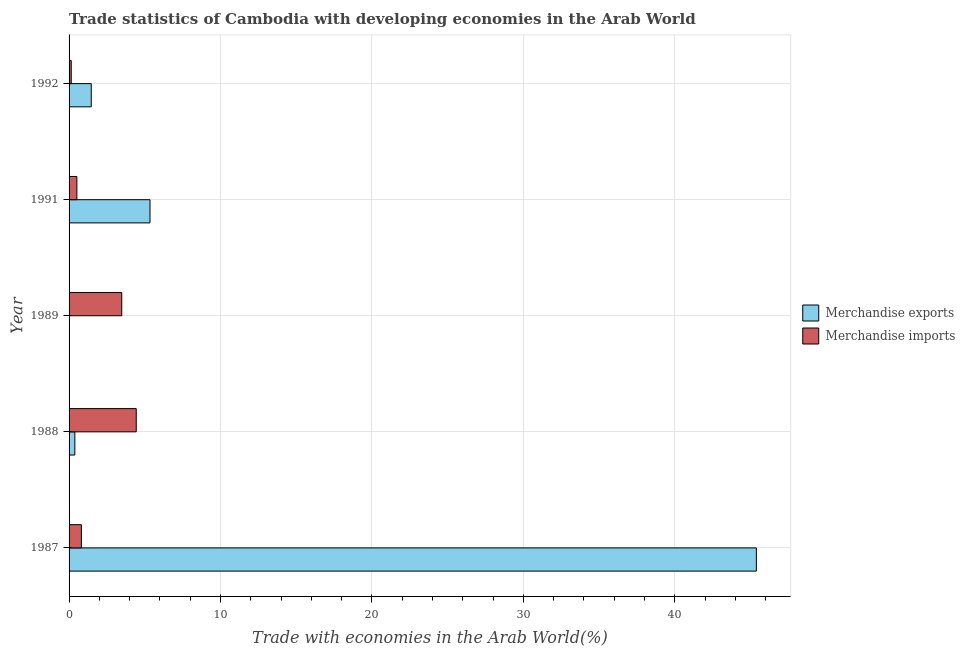Are the number of bars per tick equal to the number of legend labels?
Your answer should be very brief. Yes. How many bars are there on the 3rd tick from the top?
Keep it short and to the point. 2. How many bars are there on the 2nd tick from the bottom?
Offer a very short reply. 2. What is the label of the 3rd group of bars from the top?
Offer a very short reply. 1989. What is the merchandise exports in 1991?
Offer a terse response. 5.34. Across all years, what is the maximum merchandise exports?
Keep it short and to the point. 45.39. Across all years, what is the minimum merchandise exports?
Make the answer very short. 0.03. In which year was the merchandise exports minimum?
Your answer should be compact. 1989. What is the total merchandise exports in the graph?
Offer a very short reply. 52.61. What is the difference between the merchandise exports in 1987 and that in 1991?
Provide a short and direct response. 40.04. What is the difference between the merchandise imports in 1992 and the merchandise exports in 1987?
Provide a succinct answer. -45.24. What is the average merchandise imports per year?
Your response must be concise. 1.88. In the year 1987, what is the difference between the merchandise exports and merchandise imports?
Offer a very short reply. 44.58. In how many years, is the merchandise exports greater than 34 %?
Your answer should be compact. 1. What is the ratio of the merchandise exports in 1988 to that in 1991?
Provide a succinct answer. 0.07. Is the difference between the merchandise imports in 1991 and 1992 greater than the difference between the merchandise exports in 1991 and 1992?
Provide a short and direct response. No. What is the difference between the highest and the second highest merchandise exports?
Provide a short and direct response. 40.04. What is the difference between the highest and the lowest merchandise imports?
Your response must be concise. 4.29. Is the sum of the merchandise exports in 1987 and 1991 greater than the maximum merchandise imports across all years?
Your answer should be compact. Yes. What does the 1st bar from the top in 1987 represents?
Keep it short and to the point. Merchandise imports. What does the 2nd bar from the bottom in 1987 represents?
Your answer should be compact. Merchandise imports. How many bars are there?
Your response must be concise. 10. Are all the bars in the graph horizontal?
Your answer should be very brief. Yes. Are the values on the major ticks of X-axis written in scientific E-notation?
Provide a short and direct response. No. Does the graph contain any zero values?
Offer a terse response. No. Where does the legend appear in the graph?
Your response must be concise. Center right. How are the legend labels stacked?
Give a very brief answer. Vertical. What is the title of the graph?
Your answer should be compact. Trade statistics of Cambodia with developing economies in the Arab World. Does "Age 65(female)" appear as one of the legend labels in the graph?
Ensure brevity in your answer.  No. What is the label or title of the X-axis?
Keep it short and to the point. Trade with economies in the Arab World(%). What is the Trade with economies in the Arab World(%) in Merchandise exports in 1987?
Offer a terse response. 45.39. What is the Trade with economies in the Arab World(%) of Merchandise imports in 1987?
Provide a short and direct response. 0.81. What is the Trade with economies in the Arab World(%) in Merchandise exports in 1988?
Give a very brief answer. 0.38. What is the Trade with economies in the Arab World(%) of Merchandise imports in 1988?
Provide a succinct answer. 4.44. What is the Trade with economies in the Arab World(%) of Merchandise exports in 1989?
Your response must be concise. 0.03. What is the Trade with economies in the Arab World(%) of Merchandise imports in 1989?
Your answer should be compact. 3.48. What is the Trade with economies in the Arab World(%) of Merchandise exports in 1991?
Offer a terse response. 5.34. What is the Trade with economies in the Arab World(%) of Merchandise imports in 1991?
Offer a terse response. 0.52. What is the Trade with economies in the Arab World(%) in Merchandise exports in 1992?
Your answer should be compact. 1.46. What is the Trade with economies in the Arab World(%) of Merchandise imports in 1992?
Your answer should be compact. 0.14. Across all years, what is the maximum Trade with economies in the Arab World(%) of Merchandise exports?
Keep it short and to the point. 45.39. Across all years, what is the maximum Trade with economies in the Arab World(%) of Merchandise imports?
Your response must be concise. 4.44. Across all years, what is the minimum Trade with economies in the Arab World(%) in Merchandise exports?
Keep it short and to the point. 0.03. Across all years, what is the minimum Trade with economies in the Arab World(%) in Merchandise imports?
Your answer should be very brief. 0.14. What is the total Trade with economies in the Arab World(%) in Merchandise exports in the graph?
Your answer should be compact. 52.61. What is the total Trade with economies in the Arab World(%) in Merchandise imports in the graph?
Your answer should be very brief. 9.39. What is the difference between the Trade with economies in the Arab World(%) in Merchandise exports in 1987 and that in 1988?
Offer a terse response. 45.01. What is the difference between the Trade with economies in the Arab World(%) in Merchandise imports in 1987 and that in 1988?
Your response must be concise. -3.62. What is the difference between the Trade with economies in the Arab World(%) in Merchandise exports in 1987 and that in 1989?
Keep it short and to the point. 45.36. What is the difference between the Trade with economies in the Arab World(%) of Merchandise imports in 1987 and that in 1989?
Ensure brevity in your answer.  -2.67. What is the difference between the Trade with economies in the Arab World(%) in Merchandise exports in 1987 and that in 1991?
Your answer should be compact. 40.04. What is the difference between the Trade with economies in the Arab World(%) in Merchandise imports in 1987 and that in 1991?
Your response must be concise. 0.3. What is the difference between the Trade with economies in the Arab World(%) of Merchandise exports in 1987 and that in 1992?
Your answer should be compact. 43.92. What is the difference between the Trade with economies in the Arab World(%) of Merchandise imports in 1987 and that in 1992?
Give a very brief answer. 0.67. What is the difference between the Trade with economies in the Arab World(%) in Merchandise exports in 1988 and that in 1989?
Offer a very short reply. 0.35. What is the difference between the Trade with economies in the Arab World(%) in Merchandise imports in 1988 and that in 1989?
Your answer should be very brief. 0.96. What is the difference between the Trade with economies in the Arab World(%) in Merchandise exports in 1988 and that in 1991?
Give a very brief answer. -4.96. What is the difference between the Trade with economies in the Arab World(%) in Merchandise imports in 1988 and that in 1991?
Provide a short and direct response. 3.92. What is the difference between the Trade with economies in the Arab World(%) of Merchandise exports in 1988 and that in 1992?
Give a very brief answer. -1.08. What is the difference between the Trade with economies in the Arab World(%) of Merchandise imports in 1988 and that in 1992?
Keep it short and to the point. 4.29. What is the difference between the Trade with economies in the Arab World(%) in Merchandise exports in 1989 and that in 1991?
Your answer should be very brief. -5.32. What is the difference between the Trade with economies in the Arab World(%) in Merchandise imports in 1989 and that in 1991?
Your answer should be very brief. 2.96. What is the difference between the Trade with economies in the Arab World(%) of Merchandise exports in 1989 and that in 1992?
Your answer should be very brief. -1.44. What is the difference between the Trade with economies in the Arab World(%) in Merchandise imports in 1989 and that in 1992?
Your answer should be very brief. 3.34. What is the difference between the Trade with economies in the Arab World(%) in Merchandise exports in 1991 and that in 1992?
Your response must be concise. 3.88. What is the difference between the Trade with economies in the Arab World(%) of Merchandise imports in 1991 and that in 1992?
Provide a short and direct response. 0.37. What is the difference between the Trade with economies in the Arab World(%) in Merchandise exports in 1987 and the Trade with economies in the Arab World(%) in Merchandise imports in 1988?
Offer a very short reply. 40.95. What is the difference between the Trade with economies in the Arab World(%) of Merchandise exports in 1987 and the Trade with economies in the Arab World(%) of Merchandise imports in 1989?
Offer a very short reply. 41.91. What is the difference between the Trade with economies in the Arab World(%) of Merchandise exports in 1987 and the Trade with economies in the Arab World(%) of Merchandise imports in 1991?
Your answer should be compact. 44.87. What is the difference between the Trade with economies in the Arab World(%) of Merchandise exports in 1987 and the Trade with economies in the Arab World(%) of Merchandise imports in 1992?
Give a very brief answer. 45.24. What is the difference between the Trade with economies in the Arab World(%) of Merchandise exports in 1988 and the Trade with economies in the Arab World(%) of Merchandise imports in 1989?
Your response must be concise. -3.1. What is the difference between the Trade with economies in the Arab World(%) in Merchandise exports in 1988 and the Trade with economies in the Arab World(%) in Merchandise imports in 1991?
Keep it short and to the point. -0.13. What is the difference between the Trade with economies in the Arab World(%) of Merchandise exports in 1988 and the Trade with economies in the Arab World(%) of Merchandise imports in 1992?
Offer a very short reply. 0.24. What is the difference between the Trade with economies in the Arab World(%) of Merchandise exports in 1989 and the Trade with economies in the Arab World(%) of Merchandise imports in 1991?
Keep it short and to the point. -0.49. What is the difference between the Trade with economies in the Arab World(%) in Merchandise exports in 1989 and the Trade with economies in the Arab World(%) in Merchandise imports in 1992?
Make the answer very short. -0.12. What is the difference between the Trade with economies in the Arab World(%) of Merchandise exports in 1991 and the Trade with economies in the Arab World(%) of Merchandise imports in 1992?
Your answer should be compact. 5.2. What is the average Trade with economies in the Arab World(%) in Merchandise exports per year?
Offer a very short reply. 10.52. What is the average Trade with economies in the Arab World(%) in Merchandise imports per year?
Your answer should be very brief. 1.88. In the year 1987, what is the difference between the Trade with economies in the Arab World(%) in Merchandise exports and Trade with economies in the Arab World(%) in Merchandise imports?
Your answer should be very brief. 44.58. In the year 1988, what is the difference between the Trade with economies in the Arab World(%) of Merchandise exports and Trade with economies in the Arab World(%) of Merchandise imports?
Provide a succinct answer. -4.06. In the year 1989, what is the difference between the Trade with economies in the Arab World(%) of Merchandise exports and Trade with economies in the Arab World(%) of Merchandise imports?
Provide a short and direct response. -3.45. In the year 1991, what is the difference between the Trade with economies in the Arab World(%) of Merchandise exports and Trade with economies in the Arab World(%) of Merchandise imports?
Your answer should be very brief. 4.83. In the year 1992, what is the difference between the Trade with economies in the Arab World(%) in Merchandise exports and Trade with economies in the Arab World(%) in Merchandise imports?
Your response must be concise. 1.32. What is the ratio of the Trade with economies in the Arab World(%) in Merchandise exports in 1987 to that in 1988?
Your answer should be very brief. 119.03. What is the ratio of the Trade with economies in the Arab World(%) of Merchandise imports in 1987 to that in 1988?
Make the answer very short. 0.18. What is the ratio of the Trade with economies in the Arab World(%) in Merchandise exports in 1987 to that in 1989?
Offer a very short reply. 1615.07. What is the ratio of the Trade with economies in the Arab World(%) of Merchandise imports in 1987 to that in 1989?
Your response must be concise. 0.23. What is the ratio of the Trade with economies in the Arab World(%) of Merchandise exports in 1987 to that in 1991?
Ensure brevity in your answer.  8.49. What is the ratio of the Trade with economies in the Arab World(%) in Merchandise imports in 1987 to that in 1991?
Your answer should be very brief. 1.57. What is the ratio of the Trade with economies in the Arab World(%) of Merchandise exports in 1987 to that in 1992?
Keep it short and to the point. 31. What is the ratio of the Trade with economies in the Arab World(%) of Merchandise imports in 1987 to that in 1992?
Provide a succinct answer. 5.68. What is the ratio of the Trade with economies in the Arab World(%) of Merchandise exports in 1988 to that in 1989?
Make the answer very short. 13.57. What is the ratio of the Trade with economies in the Arab World(%) in Merchandise imports in 1988 to that in 1989?
Your response must be concise. 1.27. What is the ratio of the Trade with economies in the Arab World(%) of Merchandise exports in 1988 to that in 1991?
Your answer should be compact. 0.07. What is the ratio of the Trade with economies in the Arab World(%) of Merchandise imports in 1988 to that in 1991?
Provide a short and direct response. 8.6. What is the ratio of the Trade with economies in the Arab World(%) of Merchandise exports in 1988 to that in 1992?
Offer a very short reply. 0.26. What is the ratio of the Trade with economies in the Arab World(%) in Merchandise imports in 1988 to that in 1992?
Provide a short and direct response. 31. What is the ratio of the Trade with economies in the Arab World(%) in Merchandise exports in 1989 to that in 1991?
Offer a terse response. 0.01. What is the ratio of the Trade with economies in the Arab World(%) in Merchandise imports in 1989 to that in 1991?
Give a very brief answer. 6.75. What is the ratio of the Trade with economies in the Arab World(%) of Merchandise exports in 1989 to that in 1992?
Keep it short and to the point. 0.02. What is the ratio of the Trade with economies in the Arab World(%) in Merchandise imports in 1989 to that in 1992?
Your answer should be compact. 24.31. What is the ratio of the Trade with economies in the Arab World(%) in Merchandise exports in 1991 to that in 1992?
Offer a terse response. 3.65. What is the ratio of the Trade with economies in the Arab World(%) of Merchandise imports in 1991 to that in 1992?
Ensure brevity in your answer.  3.6. What is the difference between the highest and the second highest Trade with economies in the Arab World(%) in Merchandise exports?
Ensure brevity in your answer.  40.04. What is the difference between the highest and the second highest Trade with economies in the Arab World(%) of Merchandise imports?
Give a very brief answer. 0.96. What is the difference between the highest and the lowest Trade with economies in the Arab World(%) in Merchandise exports?
Keep it short and to the point. 45.36. What is the difference between the highest and the lowest Trade with economies in the Arab World(%) of Merchandise imports?
Ensure brevity in your answer.  4.29. 